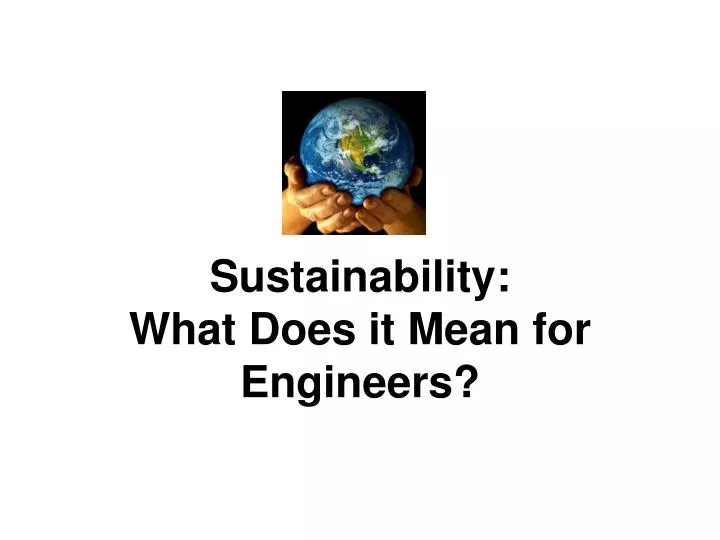Considering the central theme presented by the image, what might be the implications of the concept of sustainability for the engineering profession, and how could it influence their approach to design and innovation? The image underscores the essential role of sustainability in engineering. For the engineering profession, this implies a commitment to creating designs and innovations that are not only efficient but also environmentally conscious. Engineers are encouraged to incorporate renewable resources, reduce waste, and minimize pollution in their projects. The hands holding the globe symbolize a shared responsibility, reminding engineers to consider the long-term global impact of their work. This approach can lead to the development of sustainable infrastructures and products that ensure ecological balance and resource conservation for future generations. 